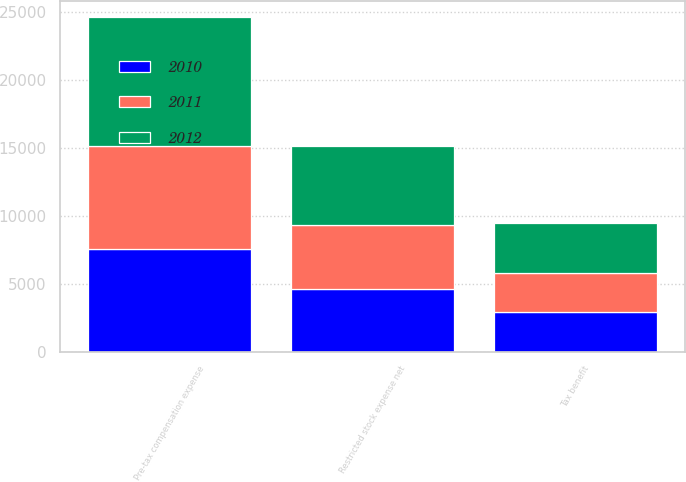<chart> <loc_0><loc_0><loc_500><loc_500><stacked_bar_chart><ecel><fcel>Pre-tax compensation expense<fcel>Tax benefit<fcel>Restricted stock expense net<nl><fcel>2012<fcel>9494<fcel>3655<fcel>5839<nl><fcel>2011<fcel>7555<fcel>2909<fcel>4646<nl><fcel>2010<fcel>7538<fcel>2902<fcel>4636<nl></chart> 